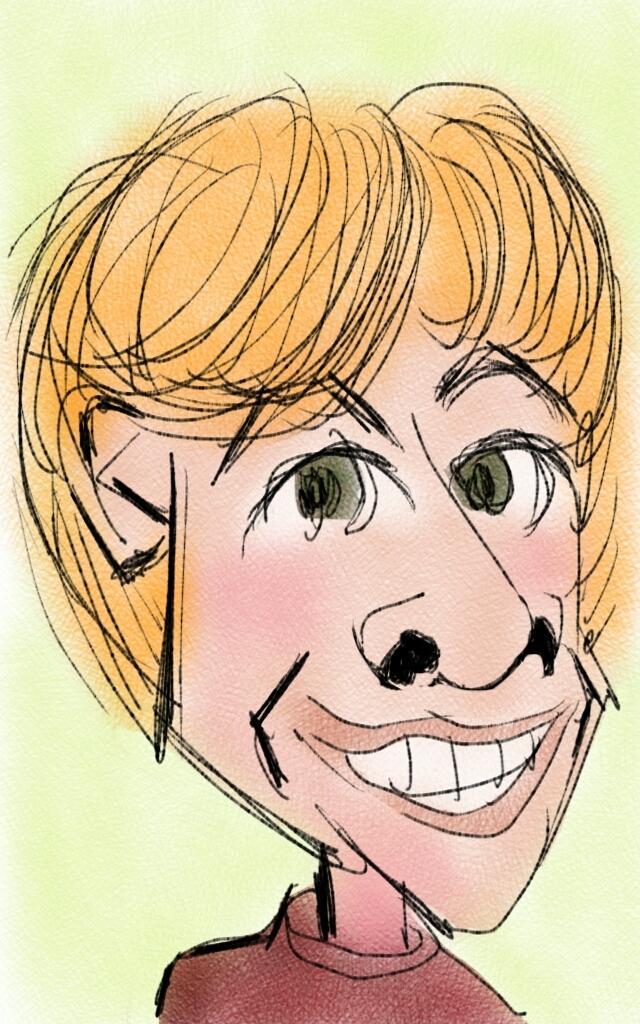Could you give a brief overview of what you see in this image? In this image we can see a cartoon picture of a person. 